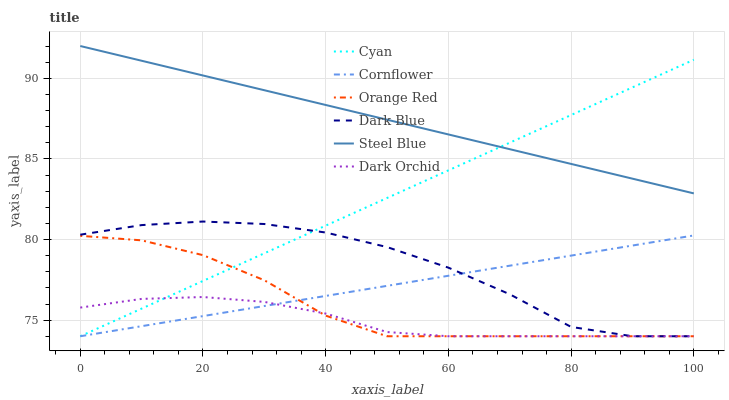Does Dark Orchid have the minimum area under the curve?
Answer yes or no. Yes. Does Steel Blue have the maximum area under the curve?
Answer yes or no. Yes. Does Steel Blue have the minimum area under the curve?
Answer yes or no. No. Does Dark Orchid have the maximum area under the curve?
Answer yes or no. No. Is Cornflower the smoothest?
Answer yes or no. Yes. Is Dark Blue the roughest?
Answer yes or no. Yes. Is Steel Blue the smoothest?
Answer yes or no. No. Is Steel Blue the roughest?
Answer yes or no. No. Does Cornflower have the lowest value?
Answer yes or no. Yes. Does Steel Blue have the lowest value?
Answer yes or no. No. Does Steel Blue have the highest value?
Answer yes or no. Yes. Does Dark Orchid have the highest value?
Answer yes or no. No. Is Dark Blue less than Steel Blue?
Answer yes or no. Yes. Is Steel Blue greater than Dark Orchid?
Answer yes or no. Yes. Does Dark Orchid intersect Cyan?
Answer yes or no. Yes. Is Dark Orchid less than Cyan?
Answer yes or no. No. Is Dark Orchid greater than Cyan?
Answer yes or no. No. Does Dark Blue intersect Steel Blue?
Answer yes or no. No. 